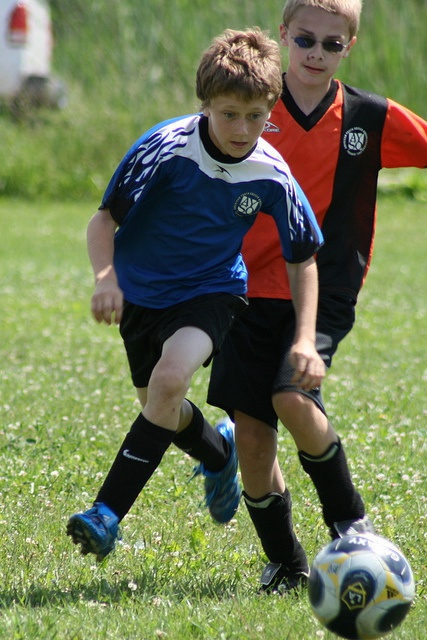Describe the objects in this image and their specific colors. I can see people in lightgray, black, navy, gray, and darkgray tones, people in lightgray, black, brown, gray, and maroon tones, sports ball in lightgray, black, white, gray, and darkgray tones, and truck in lightgray, darkgray, and gray tones in this image. 